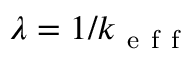<formula> <loc_0><loc_0><loc_500><loc_500>\lambda = 1 / k _ { e f f }</formula> 